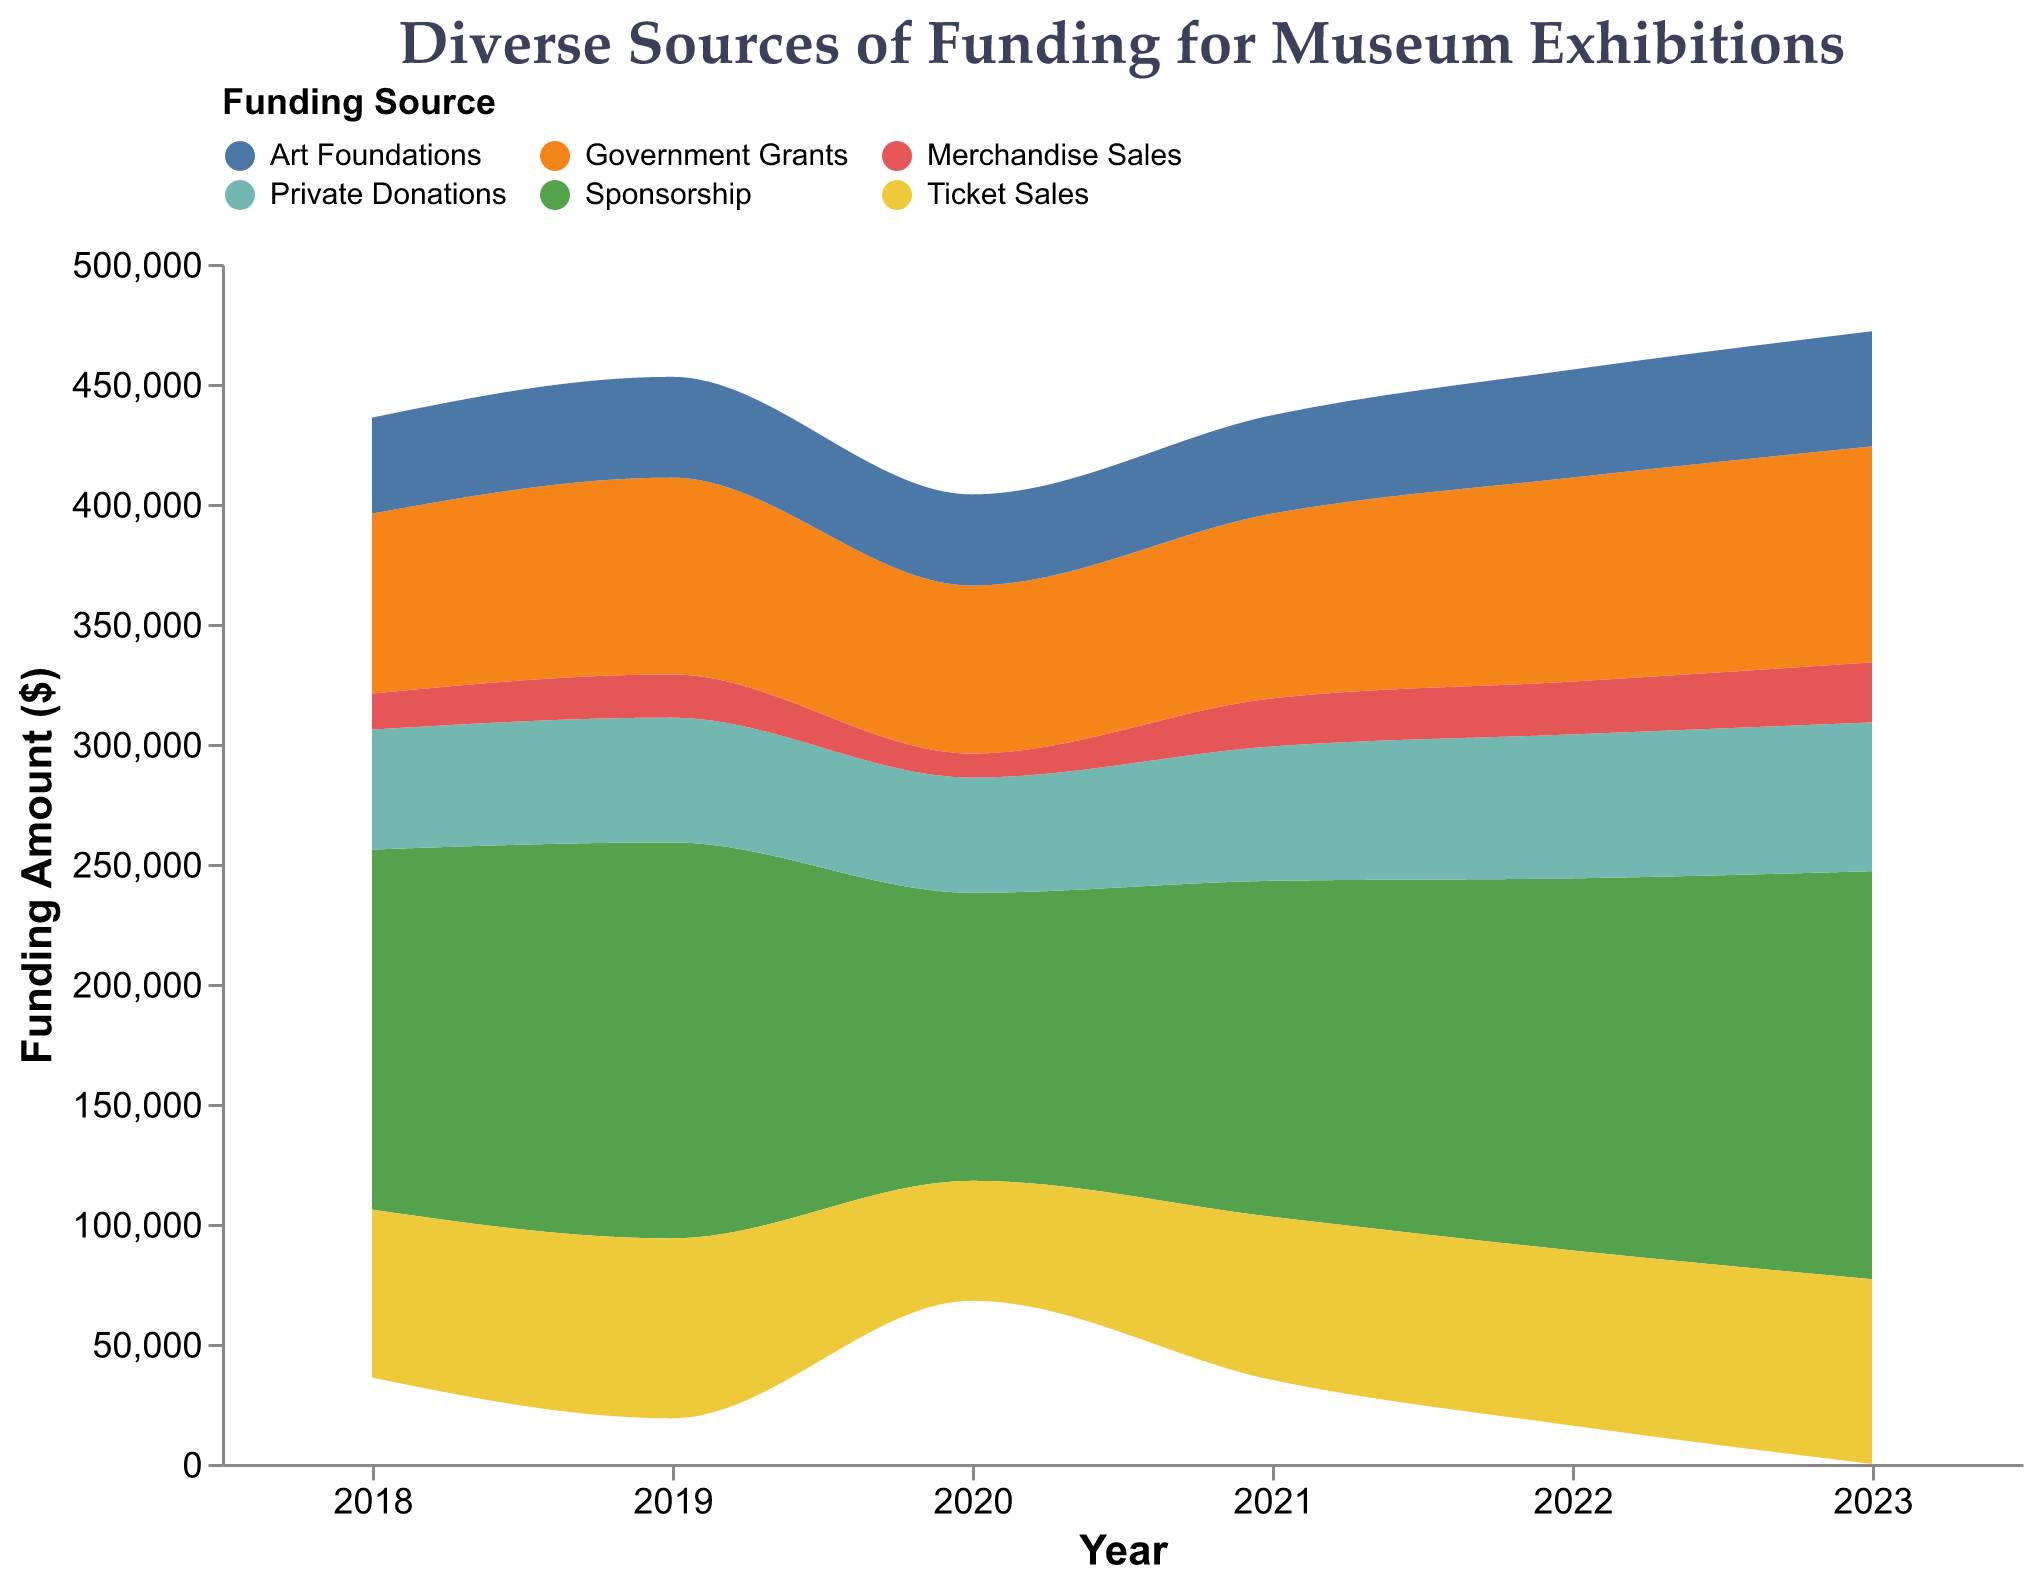What is the title of the figure? The title of the figure is displayed at the top, usually in larger text. It indicates the main subject of the visual data representation.
Answer: Diverse Sources of Funding for Museum Exhibitions What are the different sources of funding shown in the figure? The different sources are distinguished by different colors and labels in the legend. You can refer to the legend at the top for the names of each funding source.
Answer: Sponsorship, Government Grants, Private Donations, Ticket Sales, Art Foundations, Merchandise Sales Which year had the lowest total funding amount? To determine this, we need to visually assess the area representing each year by summing the heights of all stacked areas. The year with the smallest combined height will have the lowest total funding.
Answer: 2020 Which funding source shows the most consistent increase over the years? By examining each color band in the stacked area chart, the funding source that consistently expands year over year without significant drops shows the most consistent increase.
Answer: Sponsorship Compare the amount of Government Grants in 2023 to 2018. Which year received more? Look at the height of the Government Grants section in both 2023 and 2018, as indicated by its specific color and width. Compare the two heights to see which is taller, implying a higher amount.
Answer: 2023 Which funding source had the most significant drop during the year 2020? Identify the funding source by finding the color that significantly contracts from 2019 to 2020.
Answer: Ticket Sales What is the range of years displayed on the x-axis? The years are marked along the x-axis, spanning from the earliest to the latest year in the dataset.
Answer: 2018 to 2023 Calculate the total funding received from Art Foundations in 2022 and 2023 combined. Art Foundations funding in 2022 is $45,000 and in 2023 is $48,000. Add these amounts together to get the total funding for both years.
Answer: $93,000 Is there a noticeable trend in the Merchandise Sales over the years? Assess the height of the Merchandise Sales area year by year. If the section's height generally increases, we see an upward trend; otherwise, a different trend or inconsistency might be noted.
Answer: Upward trend Compare the total funding amounts for Private Donations and Ticket Sales in 2021. Which source contributed more? Look at the heights and areas representing Private Donations and Ticket Sales in 2021. Compare the two areas to see which one is larger, indicating more significant funding.
Answer: Private Donations 